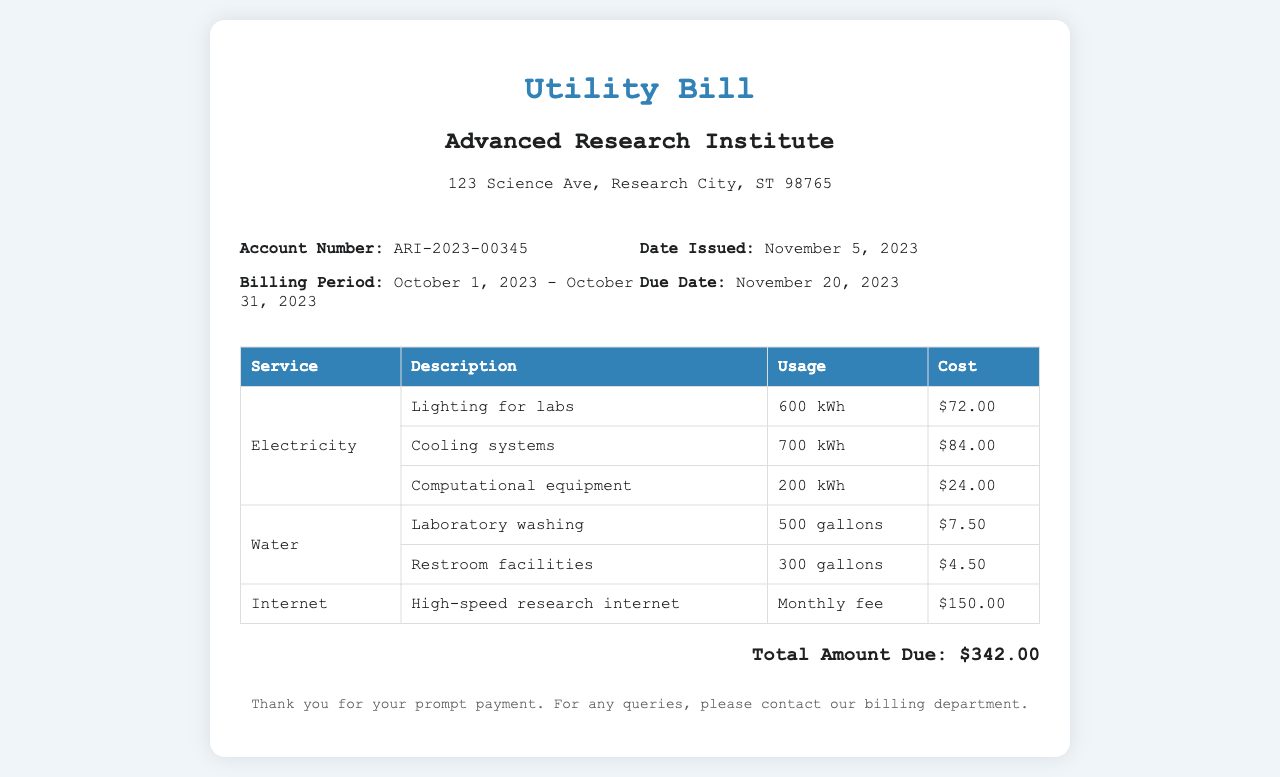What is the account number? The account number is listed in the document, which is ARI-2023-00345.
Answer: ARI-2023-00345 What is the total amount due? The total amount due is provided at the end of the utility bill, which is $342.00.
Answer: $342.00 What is the billing period? The billing period is specified in the document, from October 1, 2023 to October 31, 2023.
Answer: October 1, 2023 - October 31, 2023 How much was spent on cooling systems? The cost for cooling systems is detailed in the electricity section, which amounts to $84.00.
Answer: $84.00 What is the usage of internet services? The document specifies that the usage for internet services is a monthly fee with no specific usage quantity provided.
Answer: Monthly fee How many gallons were used for laboratory washing? The document provides the amount of water used for laboratory washing, which is 500 gallons.
Answer: 500 gallons What date was the bill issued? The bill issued date is noted in the document, which is November 5, 2023.
Answer: November 5, 2023 What is the due date for payment? The due date for the payment is clearly stated in the bill as November 20, 2023.
Answer: November 20, 2023 How much was spent on lighting for labs? The cost for lighting for labs is outlined in the electricity section, which totals $72.00.
Answer: $72.00 